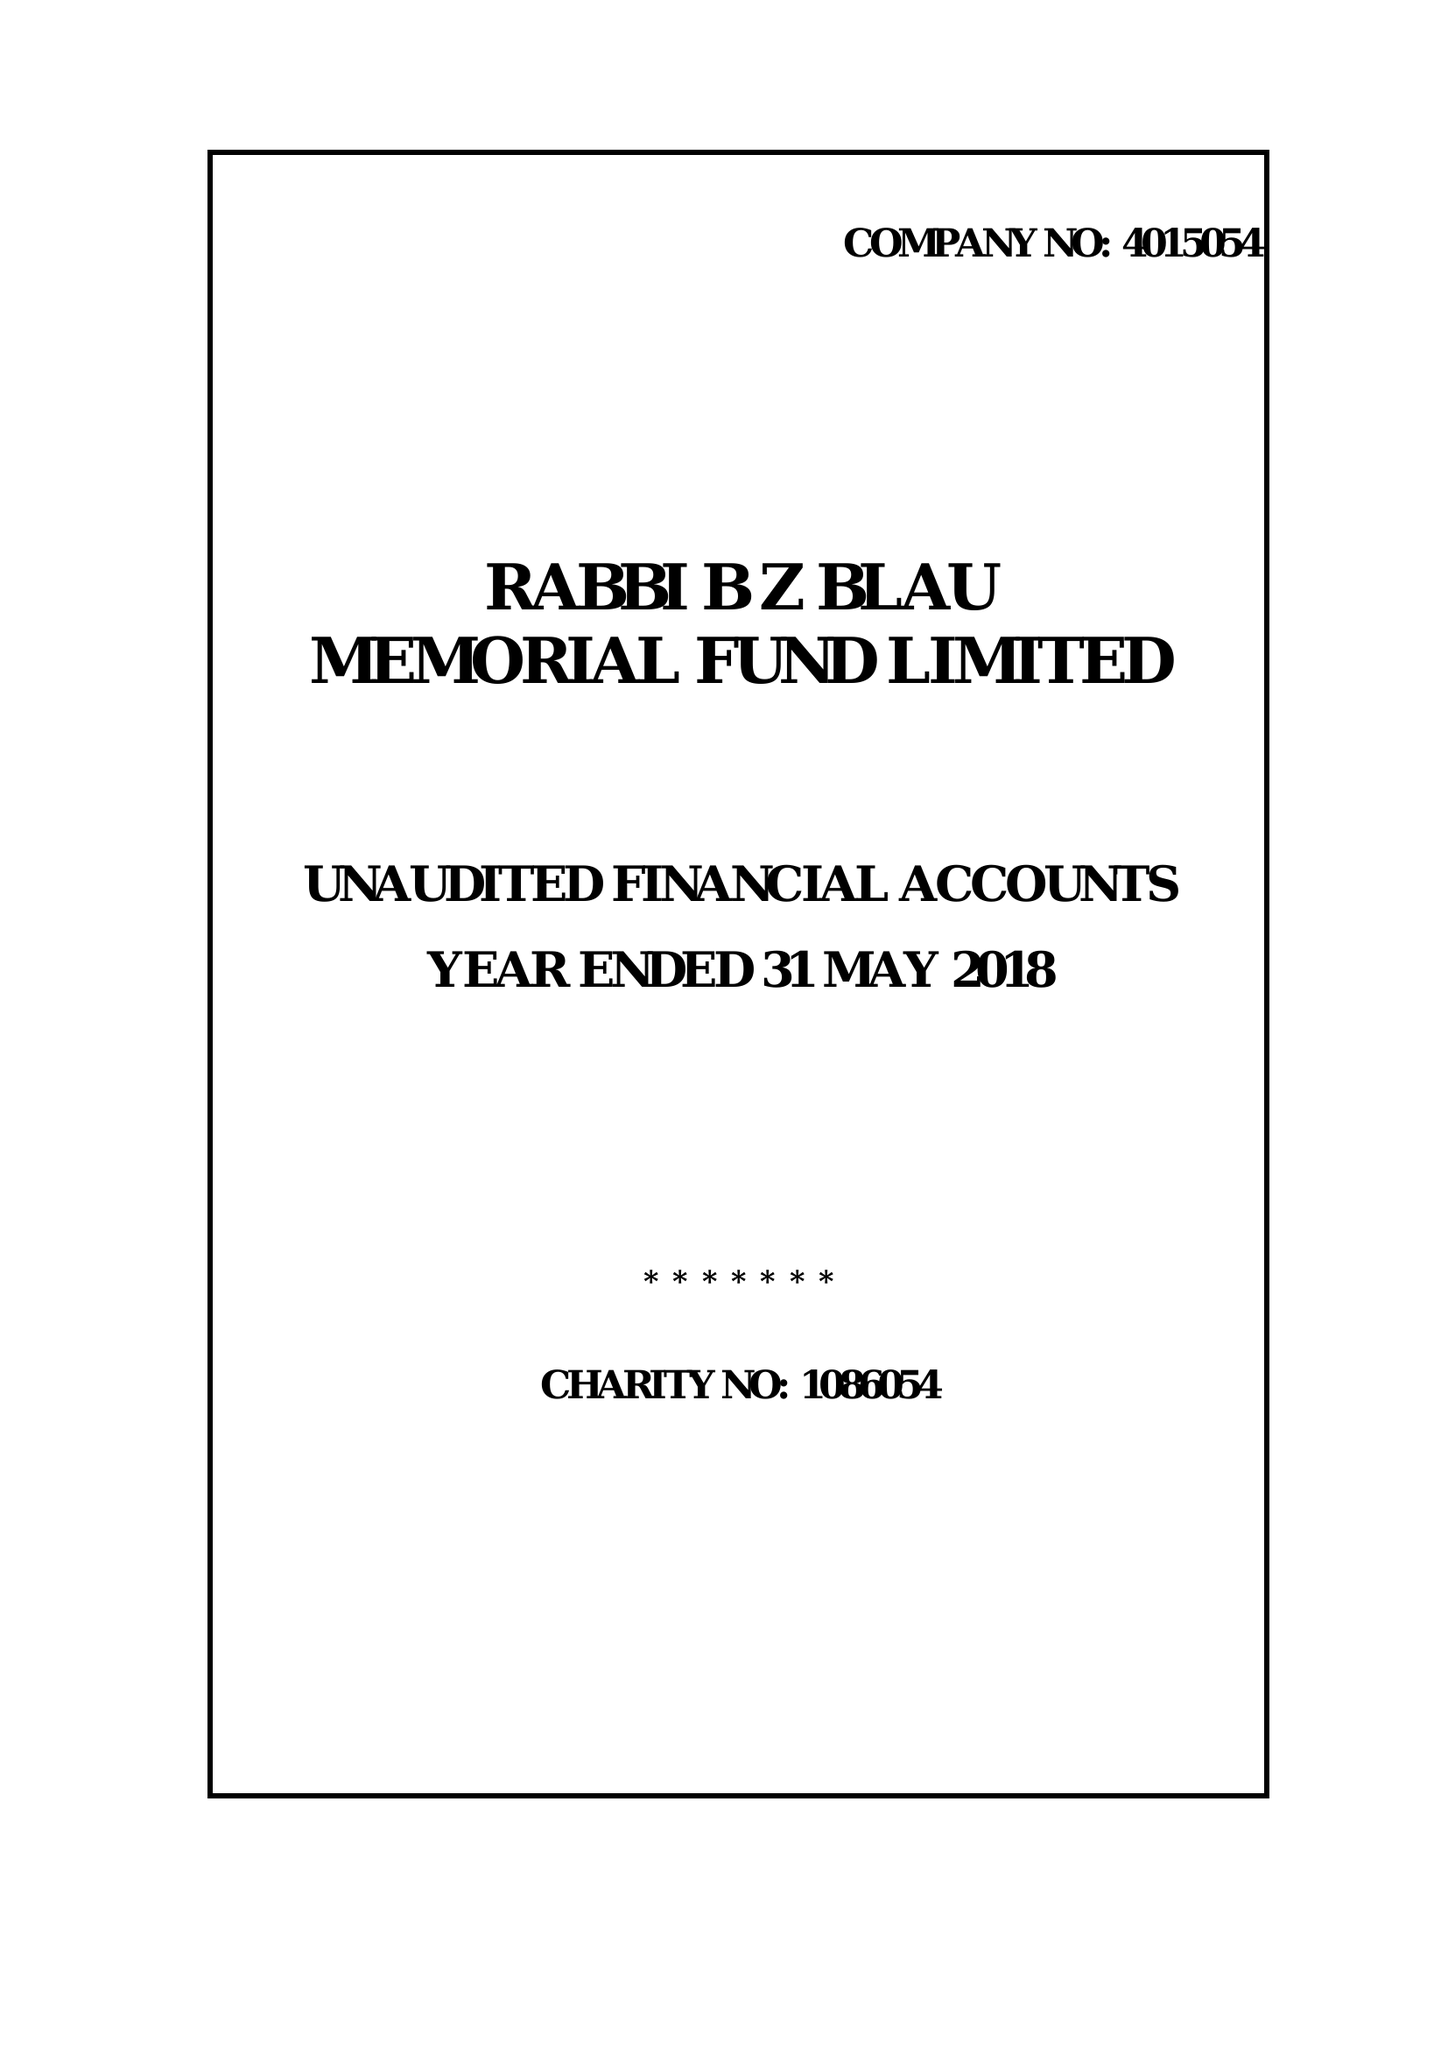What is the value for the charity_number?
Answer the question using a single word or phrase. 1086054 